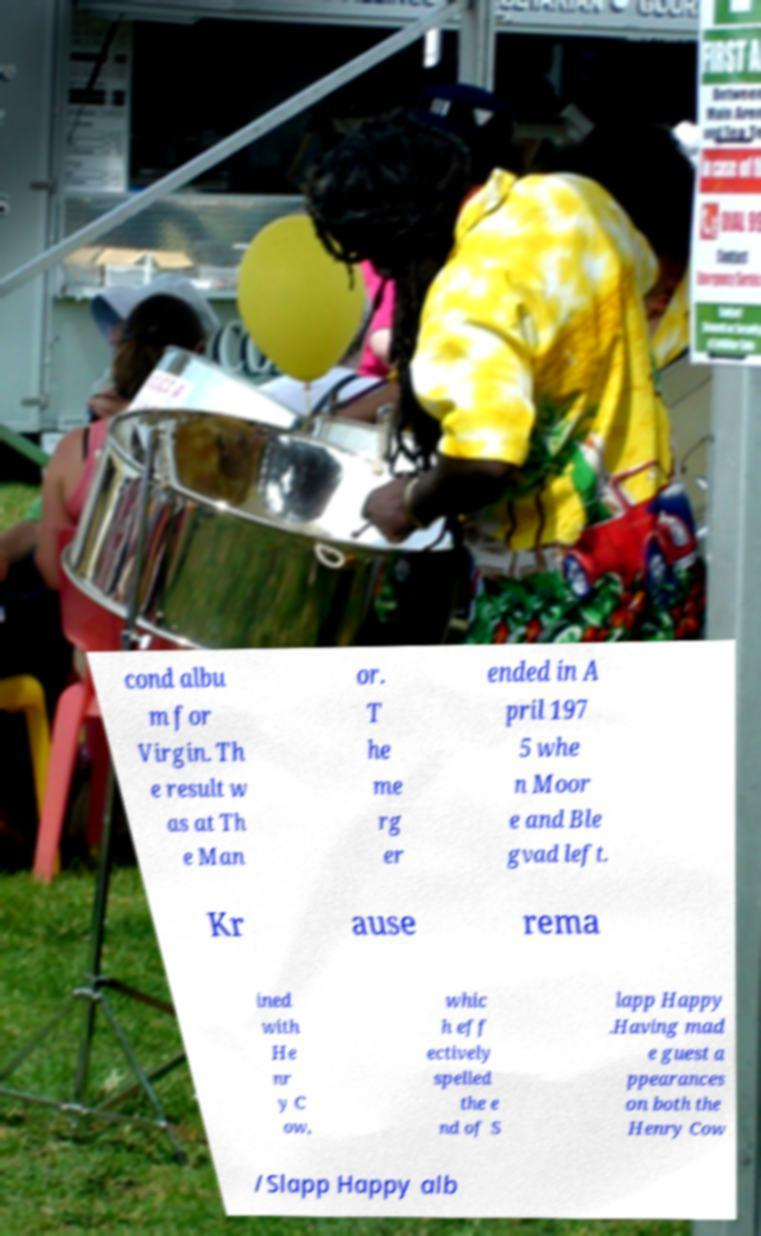There's text embedded in this image that I need extracted. Can you transcribe it verbatim? cond albu m for Virgin. Th e result w as at Th e Man or. T he me rg er ended in A pril 197 5 whe n Moor e and Ble gvad left. Kr ause rema ined with He nr y C ow, whic h eff ectively spelled the e nd of S lapp Happy .Having mad e guest a ppearances on both the Henry Cow /Slapp Happy alb 